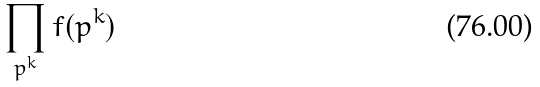Convert formula to latex. <formula><loc_0><loc_0><loc_500><loc_500>\prod _ { p ^ { k } } f ( p ^ { k } )</formula> 